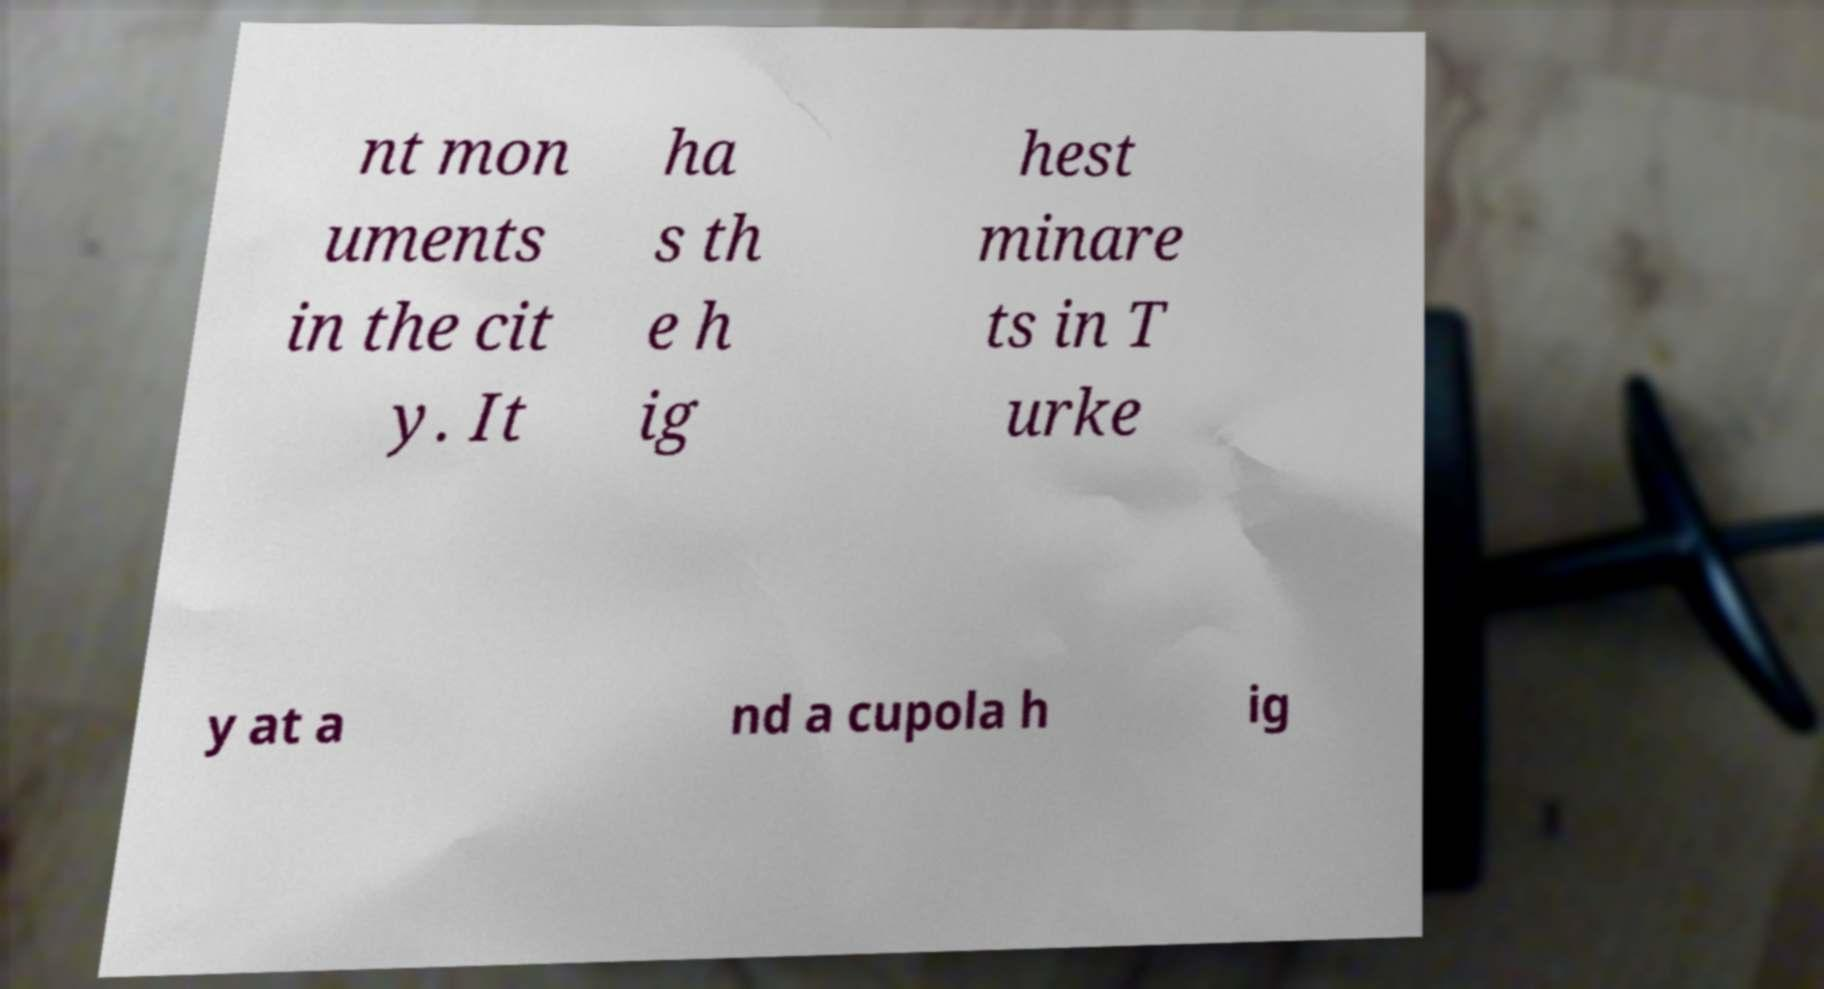Please identify and transcribe the text found in this image. nt mon uments in the cit y. It ha s th e h ig hest minare ts in T urke y at a nd a cupola h ig 